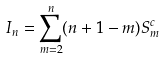Convert formula to latex. <formula><loc_0><loc_0><loc_500><loc_500>I _ { n } = \sum _ { m = 2 } ^ { n } ( n + 1 - m ) S ^ { c } _ { m }</formula> 